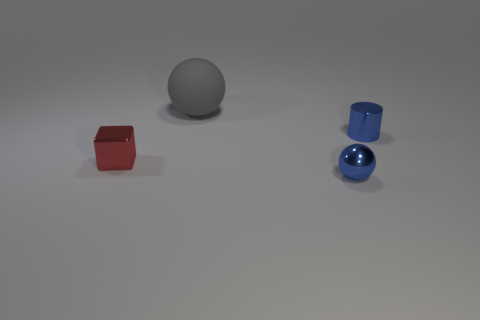There is a sphere that is behind the small metal cylinder; what color is it?
Offer a terse response. Gray. What shape is the large rubber object?
Provide a succinct answer. Sphere. There is a object behind the metal object that is behind the tiny red object; what is its material?
Make the answer very short. Rubber. How many other things are the same material as the big gray sphere?
Offer a terse response. 0. There is a blue cylinder that is the same size as the metal cube; what is its material?
Give a very brief answer. Metal. Are there more gray rubber balls behind the big matte thing than small blue balls that are behind the tiny shiny cylinder?
Offer a very short reply. No. Are there any green metallic things that have the same shape as the small red thing?
Keep it short and to the point. No. The red thing that is the same size as the shiny sphere is what shape?
Provide a short and direct response. Cube. What is the shape of the small object that is on the left side of the large gray object?
Ensure brevity in your answer.  Cube. Is the number of tiny cylinders to the right of the small ball less than the number of tiny objects that are behind the gray rubber thing?
Give a very brief answer. No. 